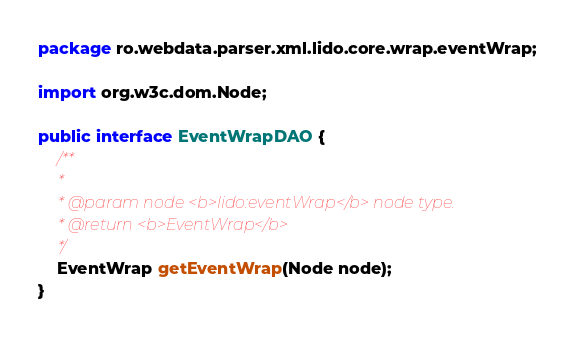<code> <loc_0><loc_0><loc_500><loc_500><_Java_>package ro.webdata.parser.xml.lido.core.wrap.eventWrap;

import org.w3c.dom.Node;

public interface EventWrapDAO {
	/**
	 *
	 * @param node <b>lido:eventWrap</b> node type.
	 * @return <b>EventWrap</b>
	 */
	EventWrap getEventWrap(Node node);
}
</code> 